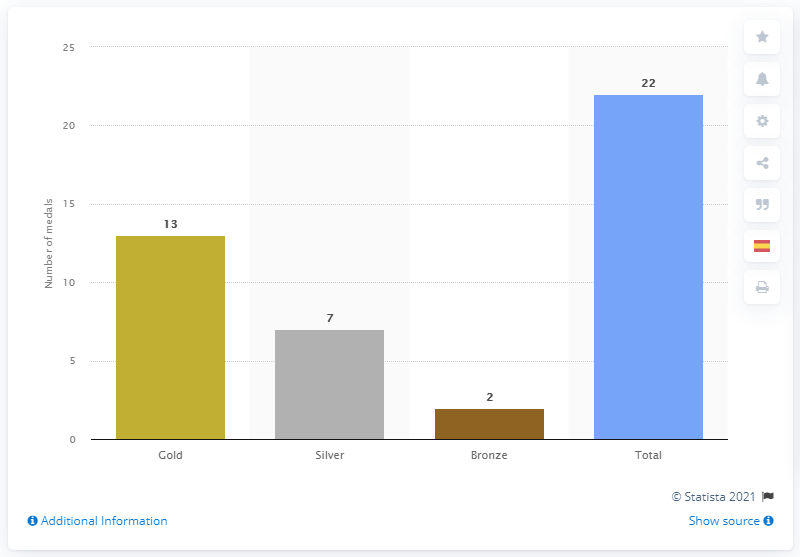Indicate a few pertinent items in this graphic. Spanish athletes won a total of 13 gold medals in the competition. 